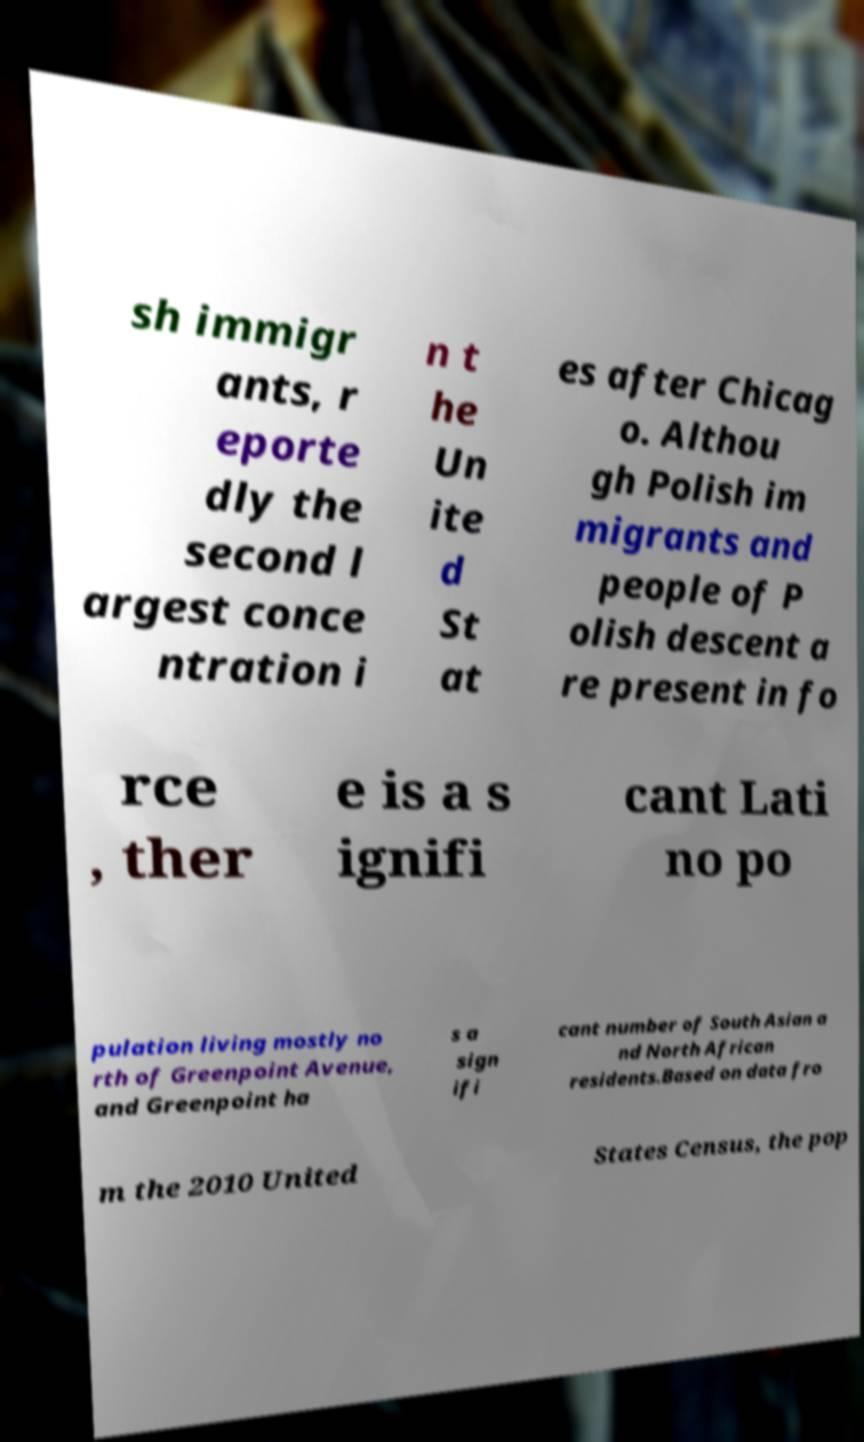Can you read and provide the text displayed in the image?This photo seems to have some interesting text. Can you extract and type it out for me? sh immigr ants, r eporte dly the second l argest conce ntration i n t he Un ite d St at es after Chicag o. Althou gh Polish im migrants and people of P olish descent a re present in fo rce , ther e is a s ignifi cant Lati no po pulation living mostly no rth of Greenpoint Avenue, and Greenpoint ha s a sign ifi cant number of South Asian a nd North African residents.Based on data fro m the 2010 United States Census, the pop 